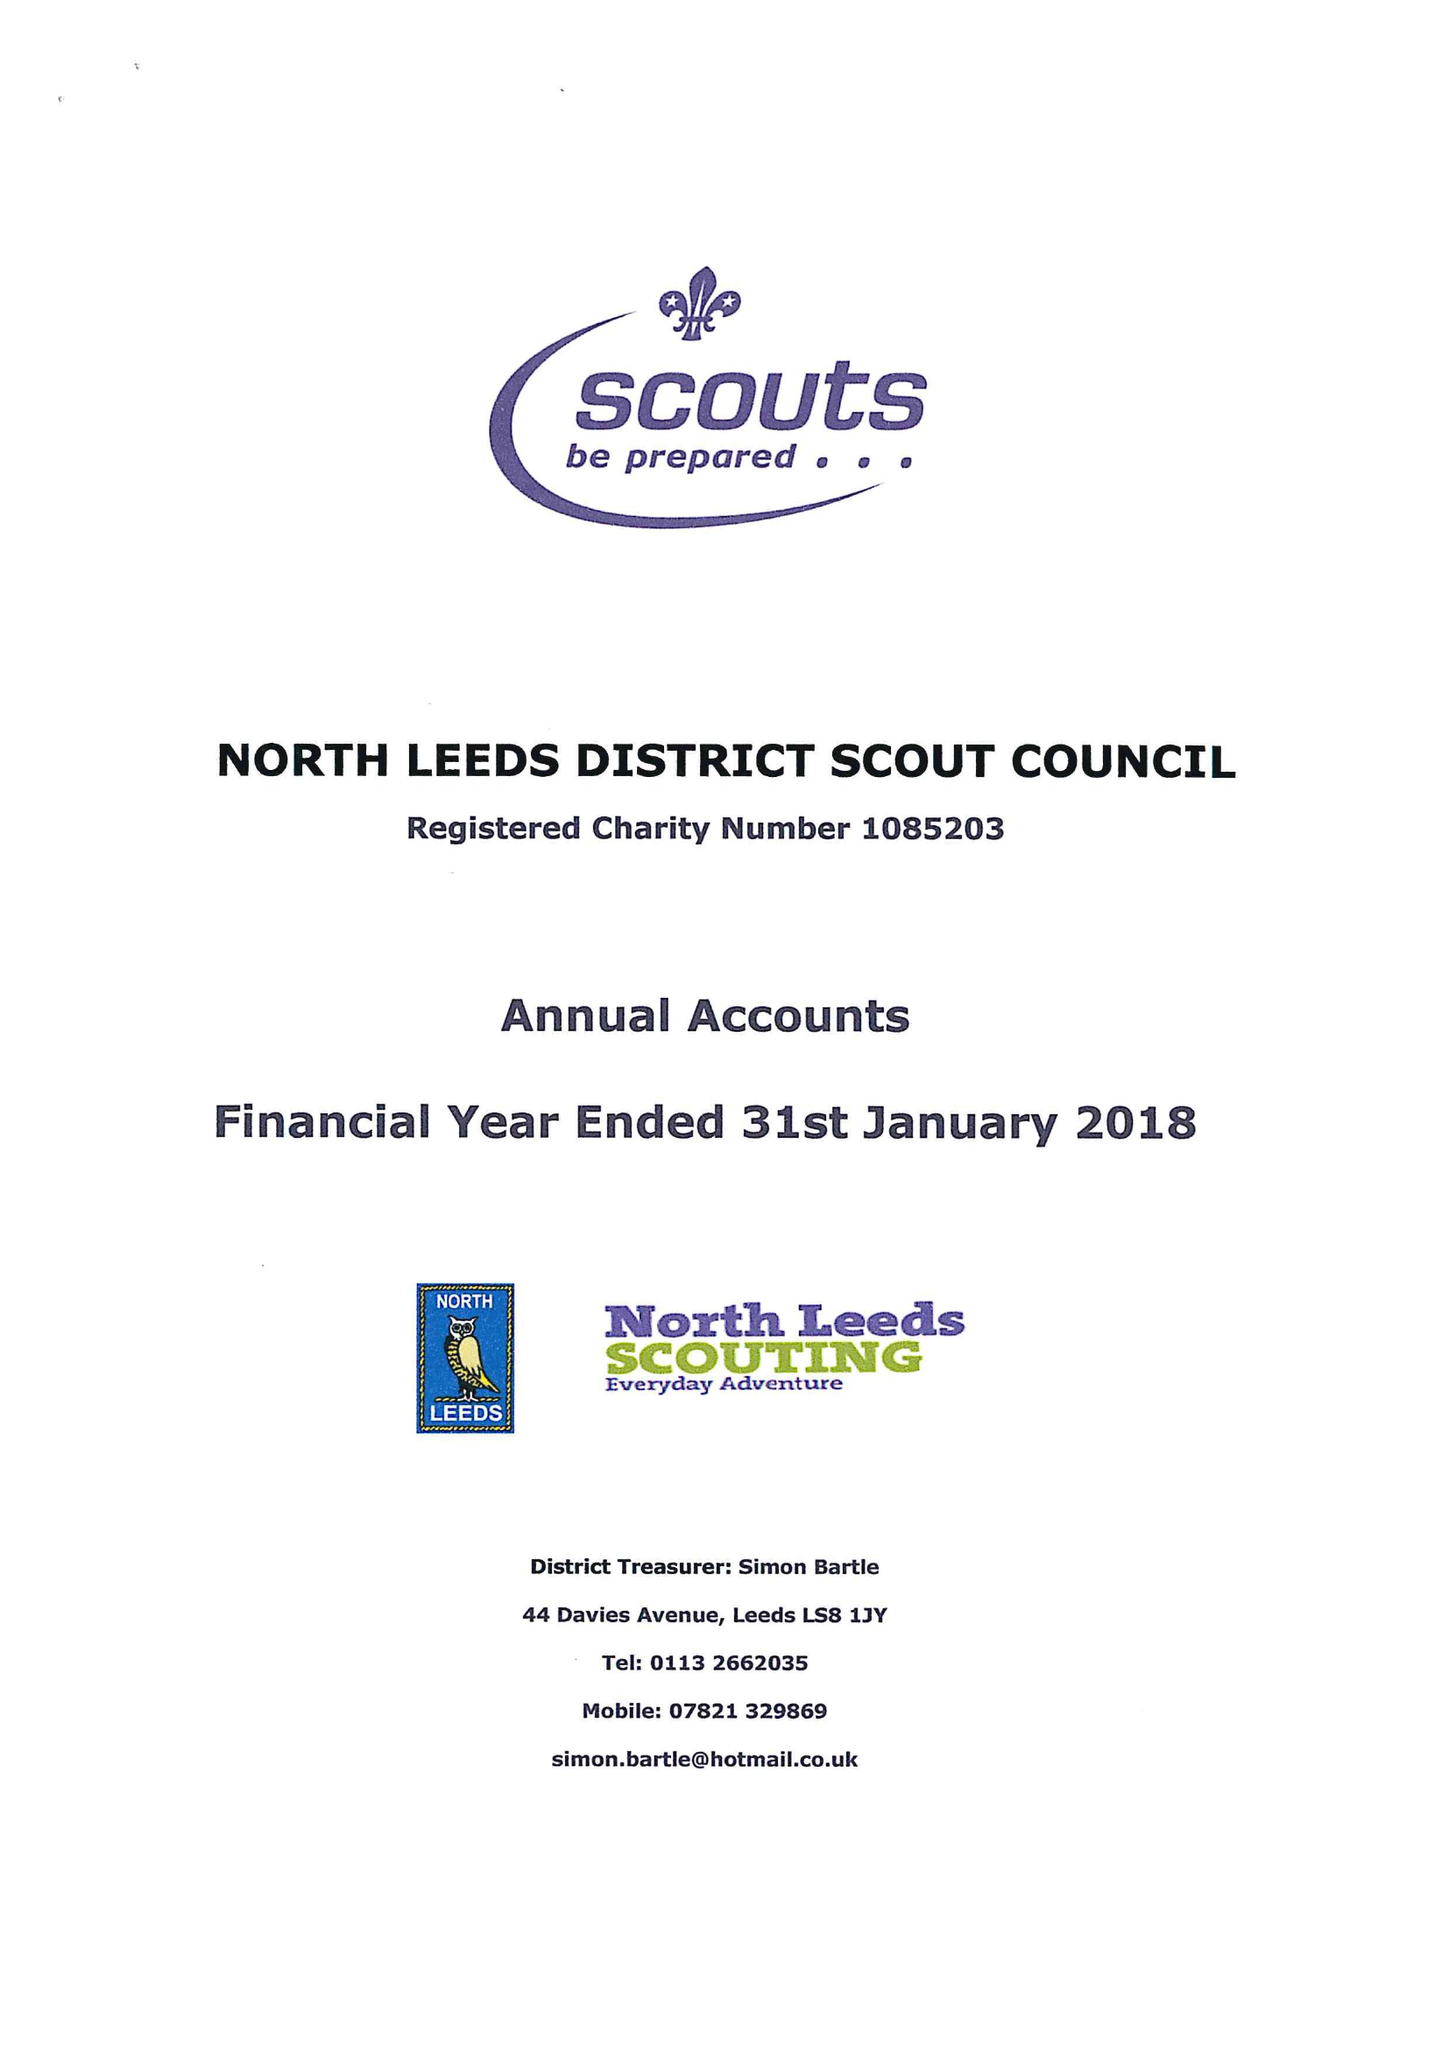What is the value for the address__post_town?
Answer the question using a single word or phrase. LEEDS 